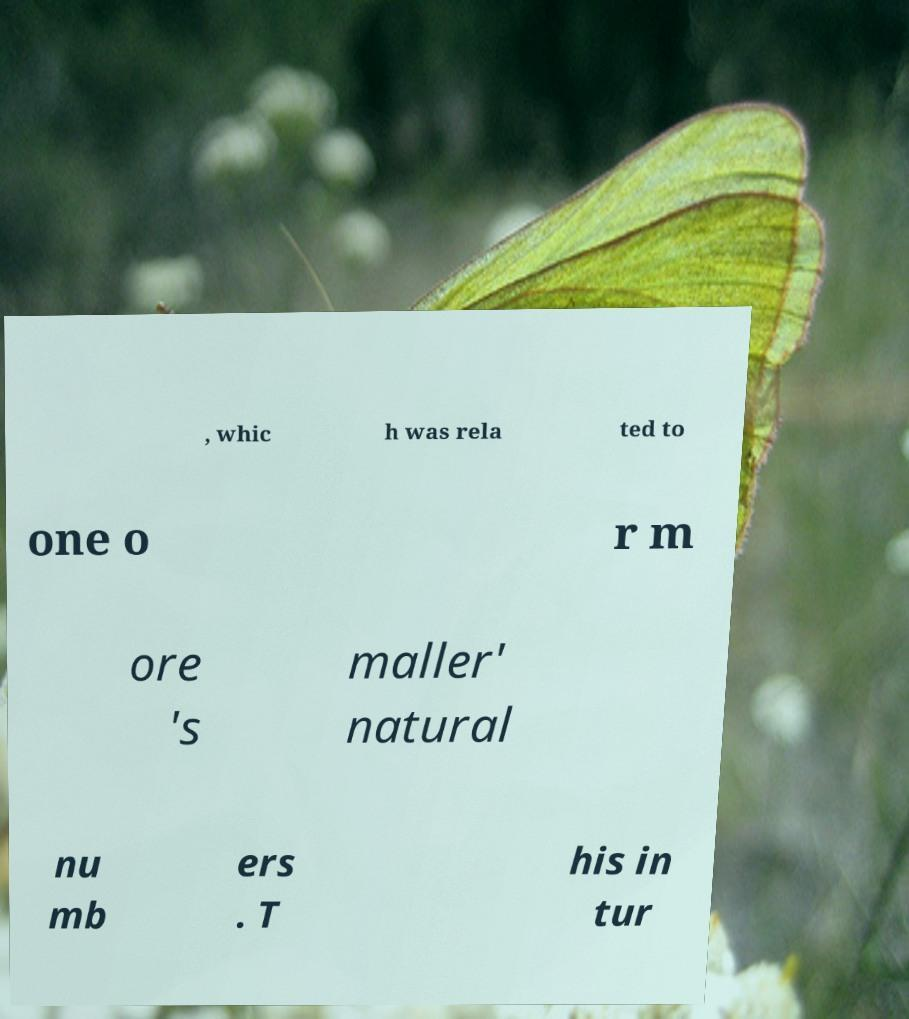Please read and relay the text visible in this image. What does it say? , whic h was rela ted to one o r m ore 's maller' natural nu mb ers . T his in tur 